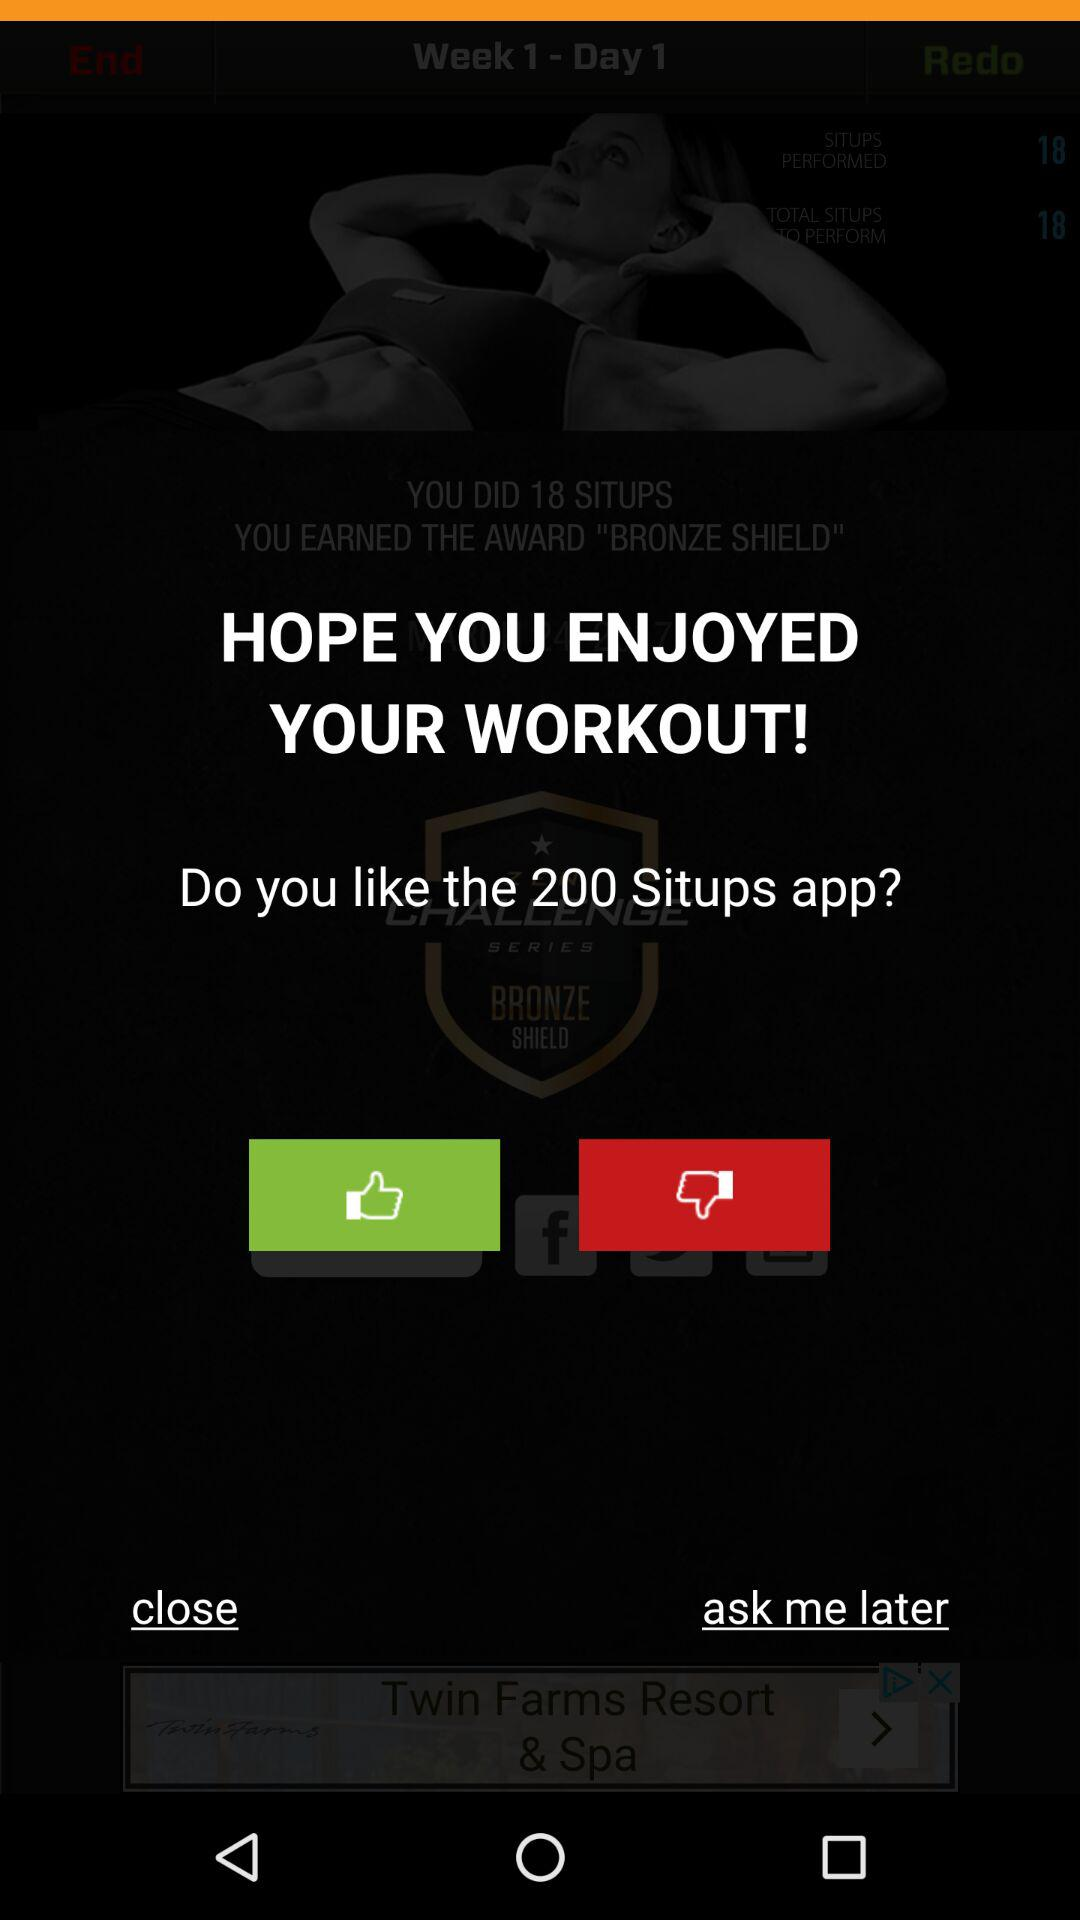How many sit-ups are targeted? The sit-ups targeted are 2264. 